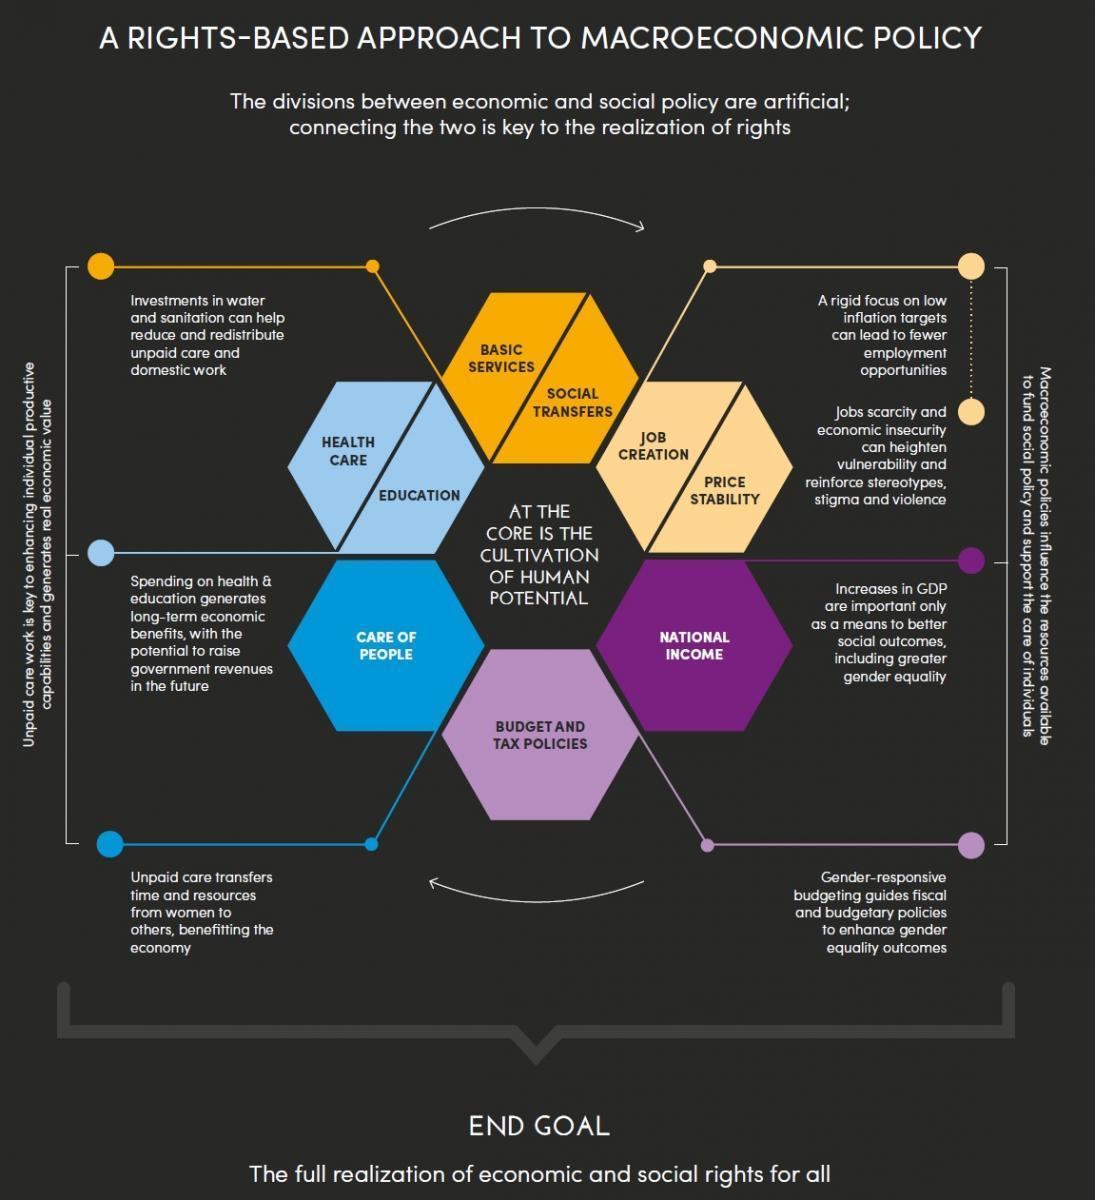How many aspects of the economy does the  Macroeconomic policies concentrate on ?
Answer the question with a short phrase. 4 Which are the two aspects of unpaid care when invested, generates income for the government in the long run ? Education, Health Care How many hexagons have been divided into two equal parts? 3 How many dimensions of unpaid care helps in improving the economy? 5 